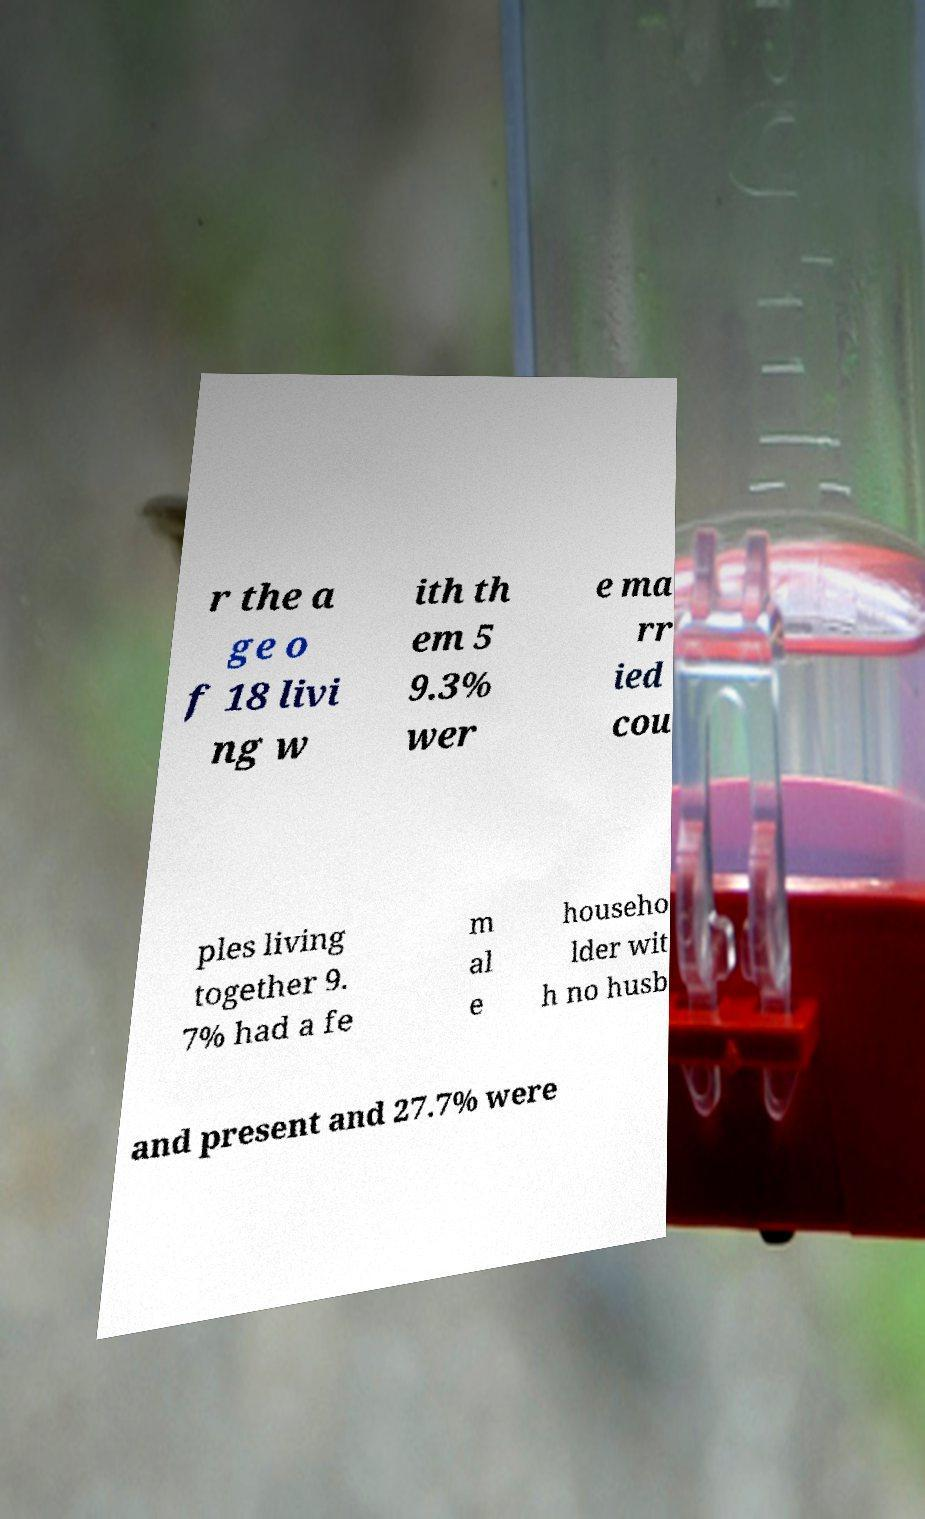Could you assist in decoding the text presented in this image and type it out clearly? r the a ge o f 18 livi ng w ith th em 5 9.3% wer e ma rr ied cou ples living together 9. 7% had a fe m al e househo lder wit h no husb and present and 27.7% were 